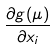Convert formula to latex. <formula><loc_0><loc_0><loc_500><loc_500>\frac { \partial g ( \mu ) } { \partial x _ { i } }</formula> 